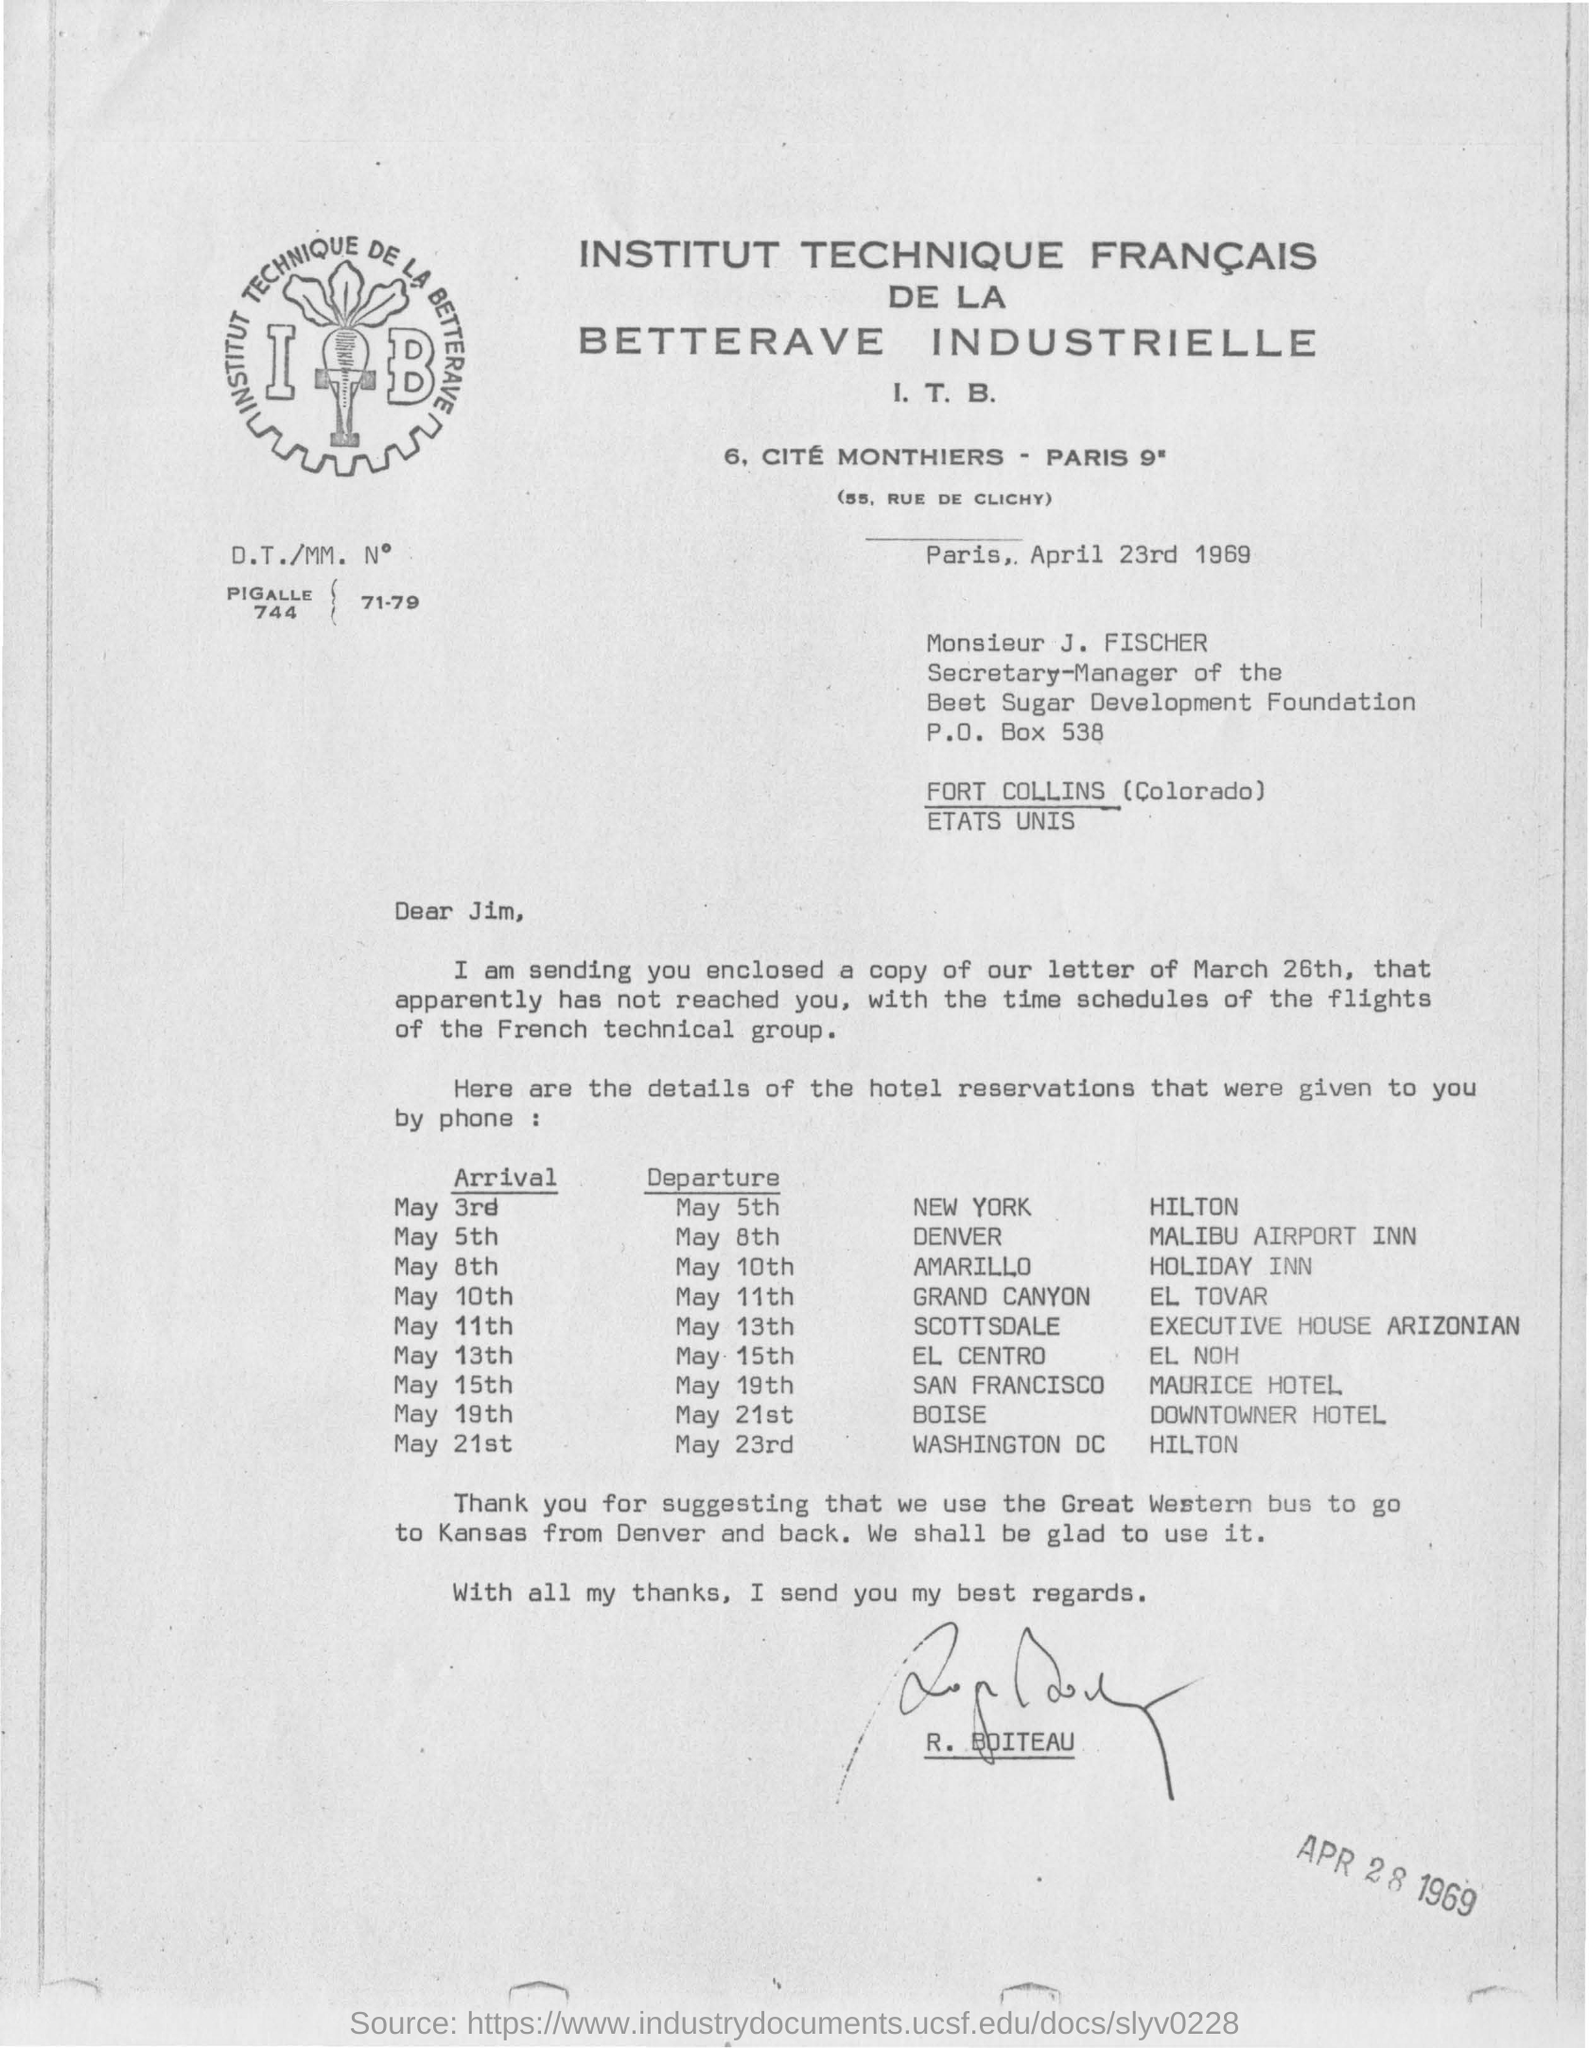Flights belongs to which group ?
Give a very brief answer. French technical group. Who is the secretary manager of the beet sugar development foundation ?
Give a very brief answer. Monsieur J. FISCHER. Which bus is used to go to kansas from denver and back ?
Your answer should be compact. Great western bus. To whom this letter was written ?
Offer a very short reply. Jim. What is the name of the hotel in newyork ?
Your answer should be compact. Hilton. 